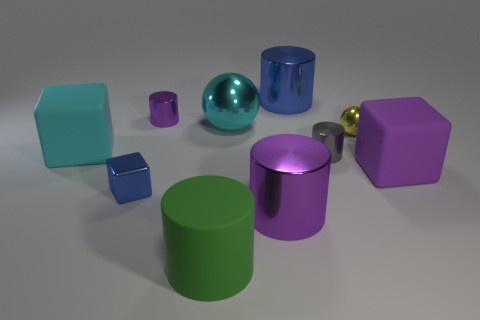Are there any tiny metallic cubes behind the gray object?
Provide a succinct answer. No. There is a cyan object on the left side of the blue block; are there any small blue shiny things that are behind it?
Give a very brief answer. No. Does the purple metallic cylinder that is left of the large purple cylinder have the same size as the gray object on the right side of the green cylinder?
Your answer should be compact. Yes. How many big objects are either purple cylinders or green matte cylinders?
Keep it short and to the point. 2. What is the material of the large cube to the left of the purple metal object to the right of the tiny purple metallic cylinder?
Give a very brief answer. Rubber. There is a big shiny object that is the same color as the small metallic cube; what shape is it?
Provide a short and direct response. Cylinder. Is there a tiny object made of the same material as the large blue cylinder?
Ensure brevity in your answer.  Yes. Is the cyan sphere made of the same material as the big cylinder that is behind the small blue thing?
Provide a succinct answer. Yes. What is the color of the other rubber block that is the same size as the purple block?
Offer a terse response. Cyan. What is the size of the blue thing right of the purple shiny cylinder to the right of the green rubber object?
Your answer should be very brief. Large. 